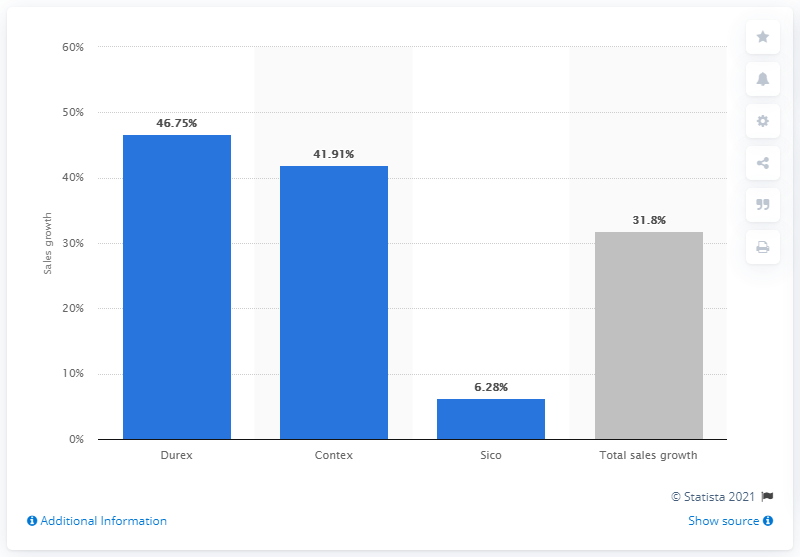Specify some key components in this picture. Durex had the highest sales growth in the eleventh week of 2020. 